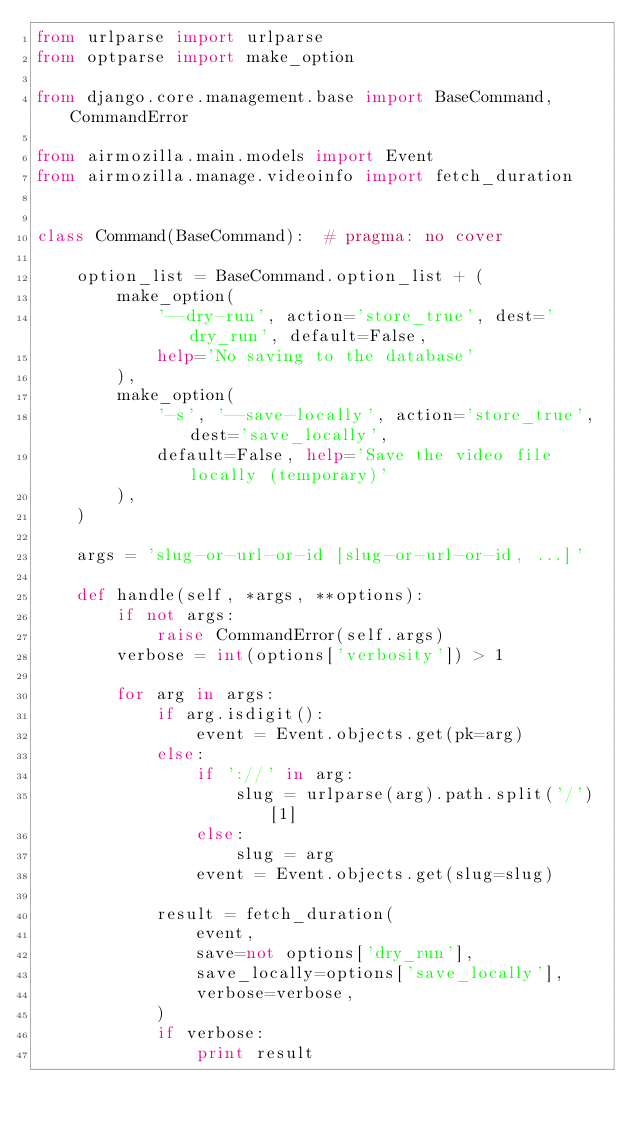Convert code to text. <code><loc_0><loc_0><loc_500><loc_500><_Python_>from urlparse import urlparse
from optparse import make_option

from django.core.management.base import BaseCommand, CommandError

from airmozilla.main.models import Event
from airmozilla.manage.videoinfo import fetch_duration


class Command(BaseCommand):  # pragma: no cover

    option_list = BaseCommand.option_list + (
        make_option(
            '--dry-run', action='store_true', dest='dry_run', default=False,
            help='No saving to the database'
        ),
        make_option(
            '-s', '--save-locally', action='store_true', dest='save_locally',
            default=False, help='Save the video file locally (temporary)'
        ),
    )

    args = 'slug-or-url-or-id [slug-or-url-or-id, ...]'

    def handle(self, *args, **options):
        if not args:
            raise CommandError(self.args)
        verbose = int(options['verbosity']) > 1

        for arg in args:
            if arg.isdigit():
                event = Event.objects.get(pk=arg)
            else:
                if '://' in arg:
                    slug = urlparse(arg).path.split('/')[1]
                else:
                    slug = arg
                event = Event.objects.get(slug=slug)

            result = fetch_duration(
                event,
                save=not options['dry_run'],
                save_locally=options['save_locally'],
                verbose=verbose,
            )
            if verbose:
                print result
</code> 